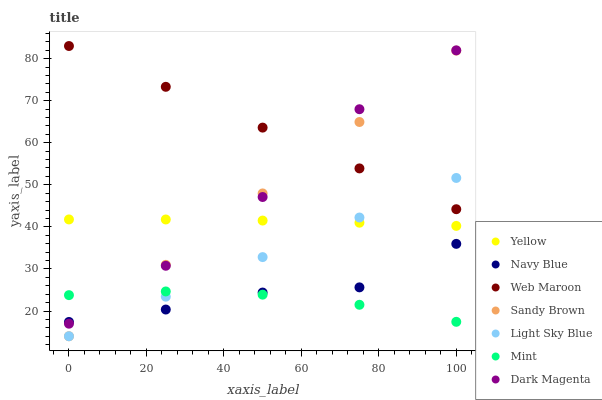Does Mint have the minimum area under the curve?
Answer yes or no. Yes. Does Web Maroon have the maximum area under the curve?
Answer yes or no. Yes. Does Navy Blue have the minimum area under the curve?
Answer yes or no. No. Does Navy Blue have the maximum area under the curve?
Answer yes or no. No. Is Sandy Brown the smoothest?
Answer yes or no. Yes. Is Dark Magenta the roughest?
Answer yes or no. Yes. Is Navy Blue the smoothest?
Answer yes or no. No. Is Navy Blue the roughest?
Answer yes or no. No. Does Light Sky Blue have the lowest value?
Answer yes or no. Yes. Does Navy Blue have the lowest value?
Answer yes or no. No. Does Web Maroon have the highest value?
Answer yes or no. Yes. Does Navy Blue have the highest value?
Answer yes or no. No. Is Mint less than Yellow?
Answer yes or no. Yes. Is Yellow greater than Mint?
Answer yes or no. Yes. Does Navy Blue intersect Sandy Brown?
Answer yes or no. Yes. Is Navy Blue less than Sandy Brown?
Answer yes or no. No. Is Navy Blue greater than Sandy Brown?
Answer yes or no. No. Does Mint intersect Yellow?
Answer yes or no. No. 